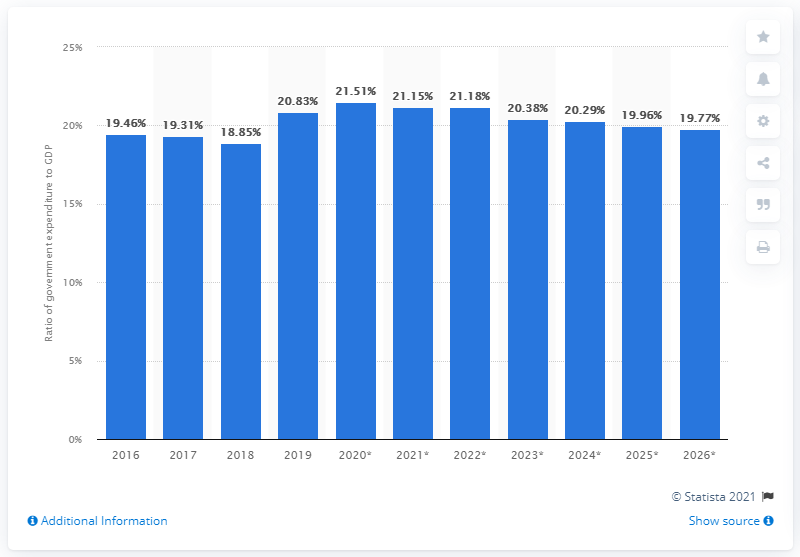Please explain the trend in government expenditure as a percentage of GDP for Sri Lanka from 2016 to 2026 as shown in the chart. The chart displays a fluctuating trend in government expenditure as a percentage of GDP in Sri Lanka from 2016 to the forecasted year of 2026. Starting at 19.46% in 2016, the ratio slightly reduced by 2018, followed by an increase peaking at approximately 21.5% between 2020 to 2021. Thereafter, projections suggest a gradual decrease, landing at an estimated 19.77% by 2026. 